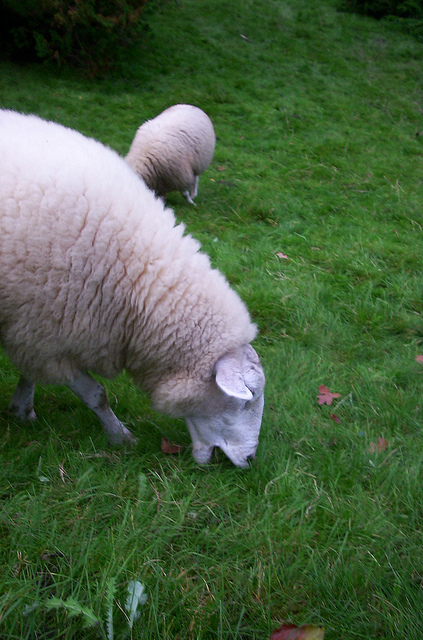<image>What religion used to sacrifice this animal to God? It is ambiguous which religion used to sacrifice this animal to God as it could be Islam, Christianity, or Jewish. What religion used to sacrifice this animal to God? I don't know what religion used to sacrifice this animal to God. It could be Islam, Judaism, or Christianity. 